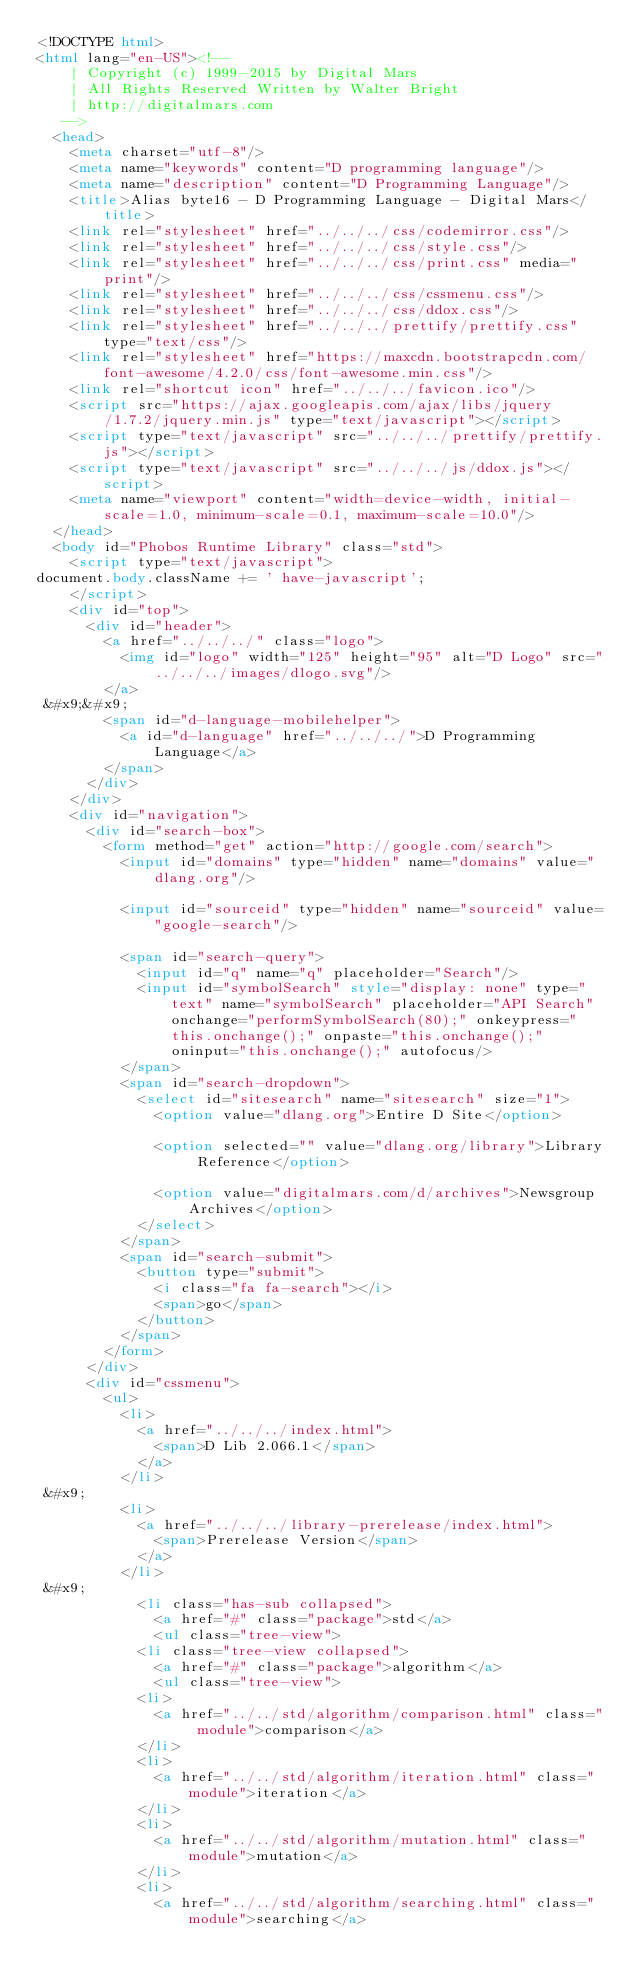Convert code to text. <code><loc_0><loc_0><loc_500><loc_500><_HTML_><!DOCTYPE html>
<html lang="en-US"><!-- 
    | Copyright (c) 1999-2015 by Digital Mars
    | All Rights Reserved Written by Walter Bright
    | http://digitalmars.com
	 -->
	<head>
		<meta charset="utf-8"/>
		<meta name="keywords" content="D programming language"/>
		<meta name="description" content="D Programming Language"/>
		<title>Alias byte16 - D Programming Language - Digital Mars</title>
		<link rel="stylesheet" href="../../../css/codemirror.css"/>
		<link rel="stylesheet" href="../../../css/style.css"/>
		<link rel="stylesheet" href="../../../css/print.css" media="print"/>
		<link rel="stylesheet" href="../../../css/cssmenu.css"/>
		<link rel="stylesheet" href="../../../css/ddox.css"/>
		<link rel="stylesheet" href="../../../prettify/prettify.css" type="text/css"/>
		<link rel="stylesheet" href="https://maxcdn.bootstrapcdn.com/font-awesome/4.2.0/css/font-awesome.min.css"/>
		<link rel="shortcut icon" href="../../../favicon.ico"/>
		<script src="https://ajax.googleapis.com/ajax/libs/jquery/1.7.2/jquery.min.js" type="text/javascript"></script>
		<script type="text/javascript" src="../../../prettify/prettify.js"></script>
		<script type="text/javascript" src="../../../js/ddox.js"></script>
		<meta name="viewport" content="width=device-width, initial-scale=1.0, minimum-scale=0.1, maximum-scale=10.0"/>
	</head>
	<body id="Phobos Runtime Library" class="std">
		<script type="text/javascript">
document.body.className += ' have-javascript';
		</script>
		<div id="top">
			<div id="header">
				<a href="../../../" class="logo">
					<img id="logo" width="125" height="95" alt="D Logo" src="../../../images/dlogo.svg"/>
				</a>
 &#x9;&#x9;
				<span id="d-language-mobilehelper">
					<a id="d-language" href="../../../">D Programming Language</a>
				</span>
			</div>
		</div>
		<div id="navigation">
			<div id="search-box">
				<form method="get" action="http://google.com/search">
					<input id="domains" type="hidden" name="domains" value="dlang.org"/>
             
					<input id="sourceid" type="hidden" name="sourceid" value="google-search"/>
             
					<span id="search-query">
						<input id="q" name="q" placeholder="Search"/>
						<input id="symbolSearch" style="display: none" type="text" name="symbolSearch" placeholder="API Search" onchange="performSymbolSearch(80);" onkeypress="this.onchange();" onpaste="this.onchange();" oninput="this.onchange();" autofocus/>
					</span>
					<span id="search-dropdown">
						<select id="sitesearch" name="sitesearch" size="1">
							<option value="dlang.org">Entire D Site</option>
                     
							<option selected="" value="dlang.org/library">Library Reference</option>
                     
							<option value="digitalmars.com/d/archives">Newsgroup Archives</option>
						</select>
					</span>
					<span id="search-submit">
						<button type="submit">
							<i class="fa fa-search"></i>
							<span>go</span>
						</button>
					</span>
				</form>
			</div>
			<div id="cssmenu">
				<ul>
					<li>
						<a href="../../../index.html">
							<span>D Lib 2.066.1</span>
						</a>
					</li>
 &#x9;
					<li>
						<a href="../../../library-prerelease/index.html">
							<span>Prerelease Version</span>
						</a>
					</li>
 &#x9;
						<li class="has-sub collapsed">
							<a href="#" class="package">std</a>
							<ul class="tree-view">
						<li class="tree-view collapsed">
							<a href="#" class="package">algorithm</a>
							<ul class="tree-view">
						<li>
							<a href="../../std/algorithm/comparison.html" class=" module">comparison</a>
						</li>
						<li>
							<a href="../../std/algorithm/iteration.html" class=" module">iteration</a>
						</li>
						<li>
							<a href="../../std/algorithm/mutation.html" class=" module">mutation</a>
						</li>
						<li>
							<a href="../../std/algorithm/searching.html" class=" module">searching</a></code> 